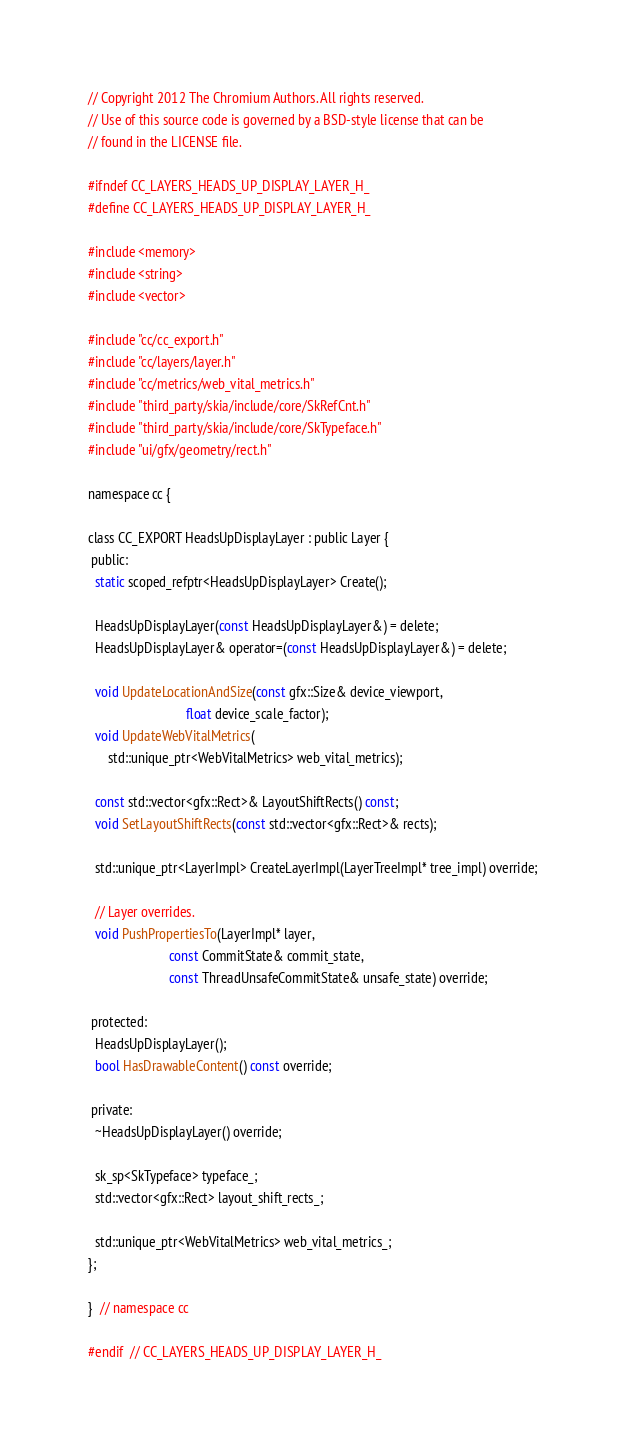Convert code to text. <code><loc_0><loc_0><loc_500><loc_500><_C_>// Copyright 2012 The Chromium Authors. All rights reserved.
// Use of this source code is governed by a BSD-style license that can be
// found in the LICENSE file.

#ifndef CC_LAYERS_HEADS_UP_DISPLAY_LAYER_H_
#define CC_LAYERS_HEADS_UP_DISPLAY_LAYER_H_

#include <memory>
#include <string>
#include <vector>

#include "cc/cc_export.h"
#include "cc/layers/layer.h"
#include "cc/metrics/web_vital_metrics.h"
#include "third_party/skia/include/core/SkRefCnt.h"
#include "third_party/skia/include/core/SkTypeface.h"
#include "ui/gfx/geometry/rect.h"

namespace cc {

class CC_EXPORT HeadsUpDisplayLayer : public Layer {
 public:
  static scoped_refptr<HeadsUpDisplayLayer> Create();

  HeadsUpDisplayLayer(const HeadsUpDisplayLayer&) = delete;
  HeadsUpDisplayLayer& operator=(const HeadsUpDisplayLayer&) = delete;

  void UpdateLocationAndSize(const gfx::Size& device_viewport,
                             float device_scale_factor);
  void UpdateWebVitalMetrics(
      std::unique_ptr<WebVitalMetrics> web_vital_metrics);

  const std::vector<gfx::Rect>& LayoutShiftRects() const;
  void SetLayoutShiftRects(const std::vector<gfx::Rect>& rects);

  std::unique_ptr<LayerImpl> CreateLayerImpl(LayerTreeImpl* tree_impl) override;

  // Layer overrides.
  void PushPropertiesTo(LayerImpl* layer,
                        const CommitState& commit_state,
                        const ThreadUnsafeCommitState& unsafe_state) override;

 protected:
  HeadsUpDisplayLayer();
  bool HasDrawableContent() const override;

 private:
  ~HeadsUpDisplayLayer() override;

  sk_sp<SkTypeface> typeface_;
  std::vector<gfx::Rect> layout_shift_rects_;

  std::unique_ptr<WebVitalMetrics> web_vital_metrics_;
};

}  // namespace cc

#endif  // CC_LAYERS_HEADS_UP_DISPLAY_LAYER_H_
</code> 